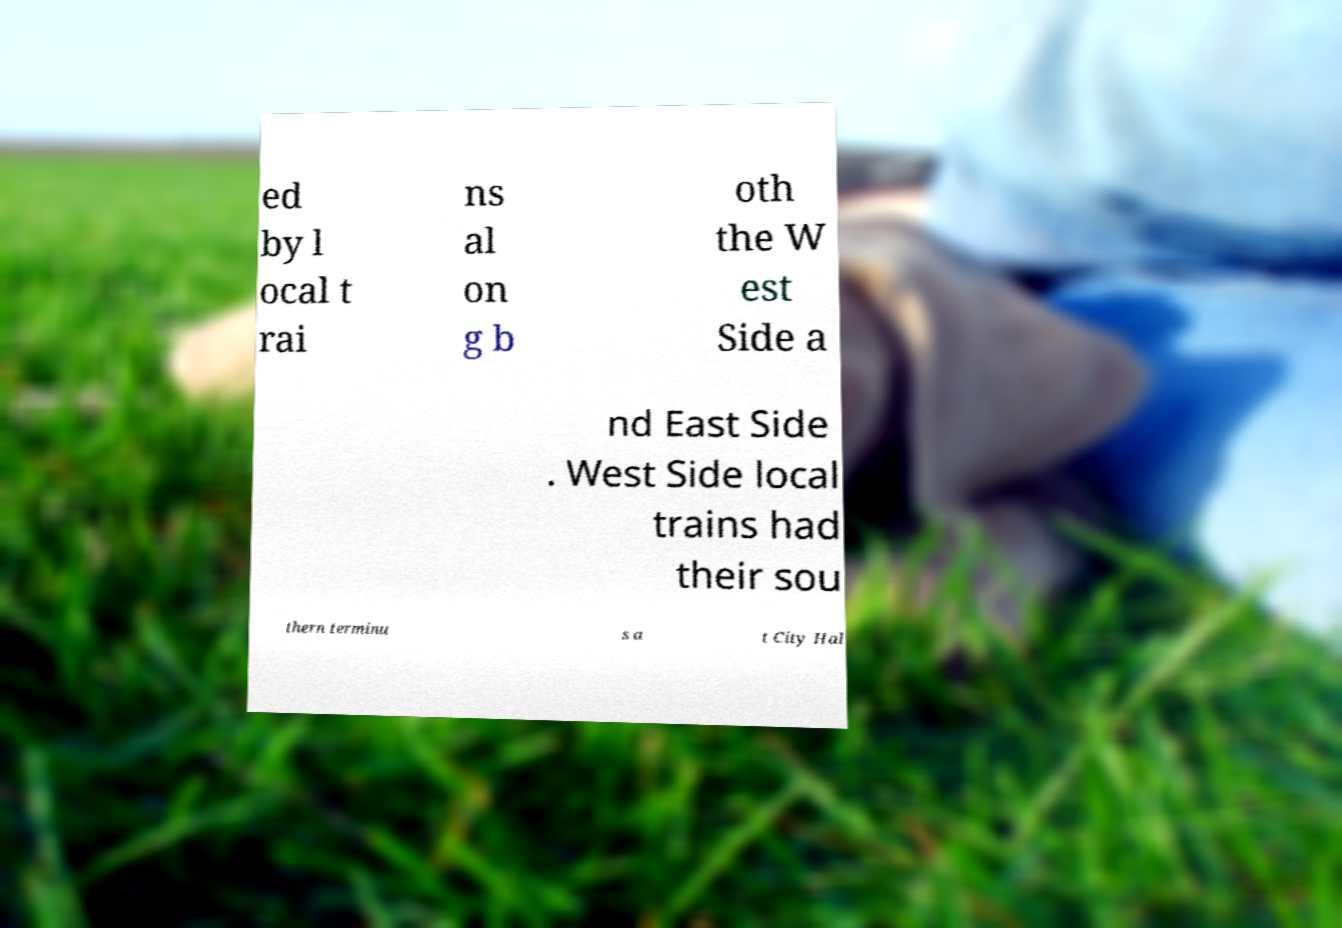Please read and relay the text visible in this image. What does it say? ed by l ocal t rai ns al on g b oth the W est Side a nd East Side . West Side local trains had their sou thern terminu s a t City Hal 